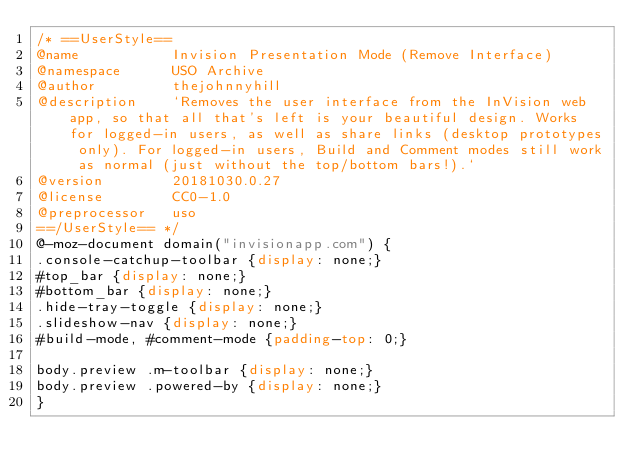Convert code to text. <code><loc_0><loc_0><loc_500><loc_500><_CSS_>/* ==UserStyle==
@name           Invision Presentation Mode (Remove Interface)
@namespace      USO Archive
@author         thejohnnyhill
@description    `Removes the user interface from the InVision web app, so that all that's left is your beautiful design. Works for logged-in users, as well as share links (desktop prototypes only). For logged-in users, Build and Comment modes still work as normal (just without the top/bottom bars!).`
@version        20181030.0.27
@license        CC0-1.0
@preprocessor   uso
==/UserStyle== */
@-moz-document domain("invisionapp.com") {
.console-catchup-toolbar {display: none;}
#top_bar {display: none;}
#bottom_bar {display: none;}
.hide-tray-toggle {display: none;}
.slideshow-nav {display: none;}
#build-mode, #comment-mode {padding-top: 0;}

body.preview .m-toolbar {display: none;}
body.preview .powered-by {display: none;}
}</code> 